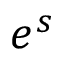<formula> <loc_0><loc_0><loc_500><loc_500>e ^ { s }</formula> 